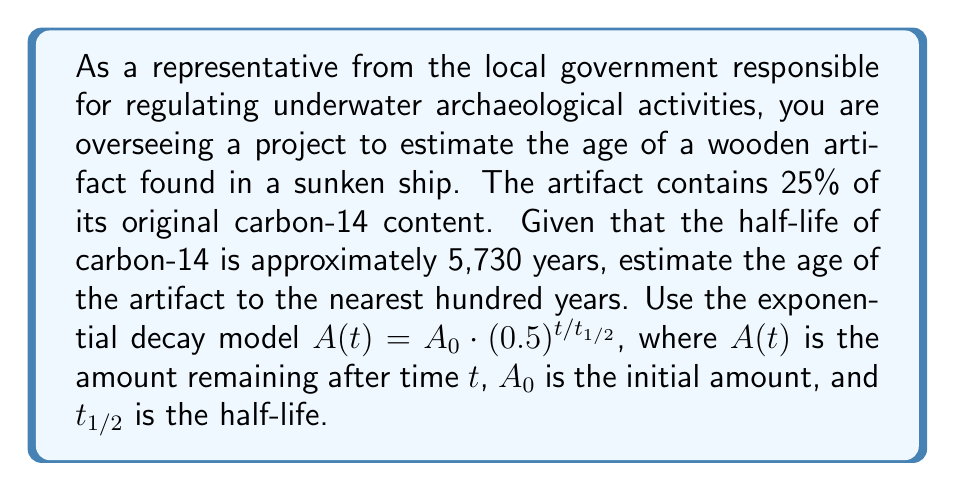Teach me how to tackle this problem. Let's approach this step-by-step:

1) We'll use the exponential decay model: $A(t) = A_0 \cdot (0.5)^{t/t_{1/2}}$

2) We know:
   - $A(t)/A_0 = 0.25$ (25% remaining)
   - $t_{1/2} = 5730$ years

3) Let's substitute these into our equation:

   $0.25 = (0.5)^{t/5730}$

4) To solve for $t$, we need to take the logarithm of both sides:

   $\log(0.25) = \log((0.5)^{t/5730})$

5) Using the logarithm property $\log(a^b) = b\log(a)$:

   $\log(0.25) = (t/5730) \cdot \log(0.5)$

6) Solve for $t$:

   $t = 5730 \cdot \frac{\log(0.25)}{\log(0.5)}$

7) Calculate:
   
   $t = 5730 \cdot \frac{\log(0.25)}{\log(0.5)} \approx 11460.8$ years

8) Rounding to the nearest hundred years:

   $t \approx 11,500$ years
Answer: The estimated age of the artifact is approximately 11,500 years. 